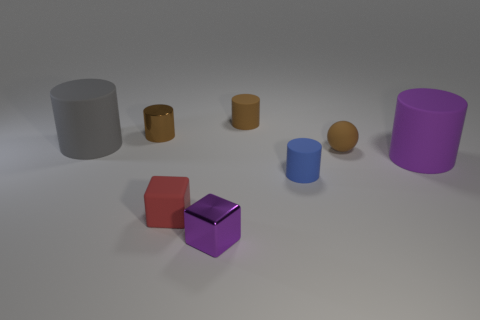What number of gray things are big cylinders or tiny matte cubes?
Offer a terse response. 1. Are there any other tiny cubes that have the same color as the metallic cube?
Your answer should be very brief. No. Is there a small purple thing made of the same material as the small blue thing?
Your answer should be very brief. No. There is a object that is both in front of the small blue rubber cylinder and on the left side of the purple cube; what shape is it?
Make the answer very short. Cube. What number of large things are either red blocks or gray objects?
Make the answer very short. 1. What material is the large gray thing?
Give a very brief answer. Rubber. What number of other objects are there of the same shape as the blue rubber thing?
Offer a terse response. 4. The gray matte thing is what size?
Offer a very short reply. Large. There is a object that is both behind the gray cylinder and right of the small red rubber object; what is its size?
Keep it short and to the point. Small. What shape is the brown rubber object in front of the large gray matte object?
Your response must be concise. Sphere. 